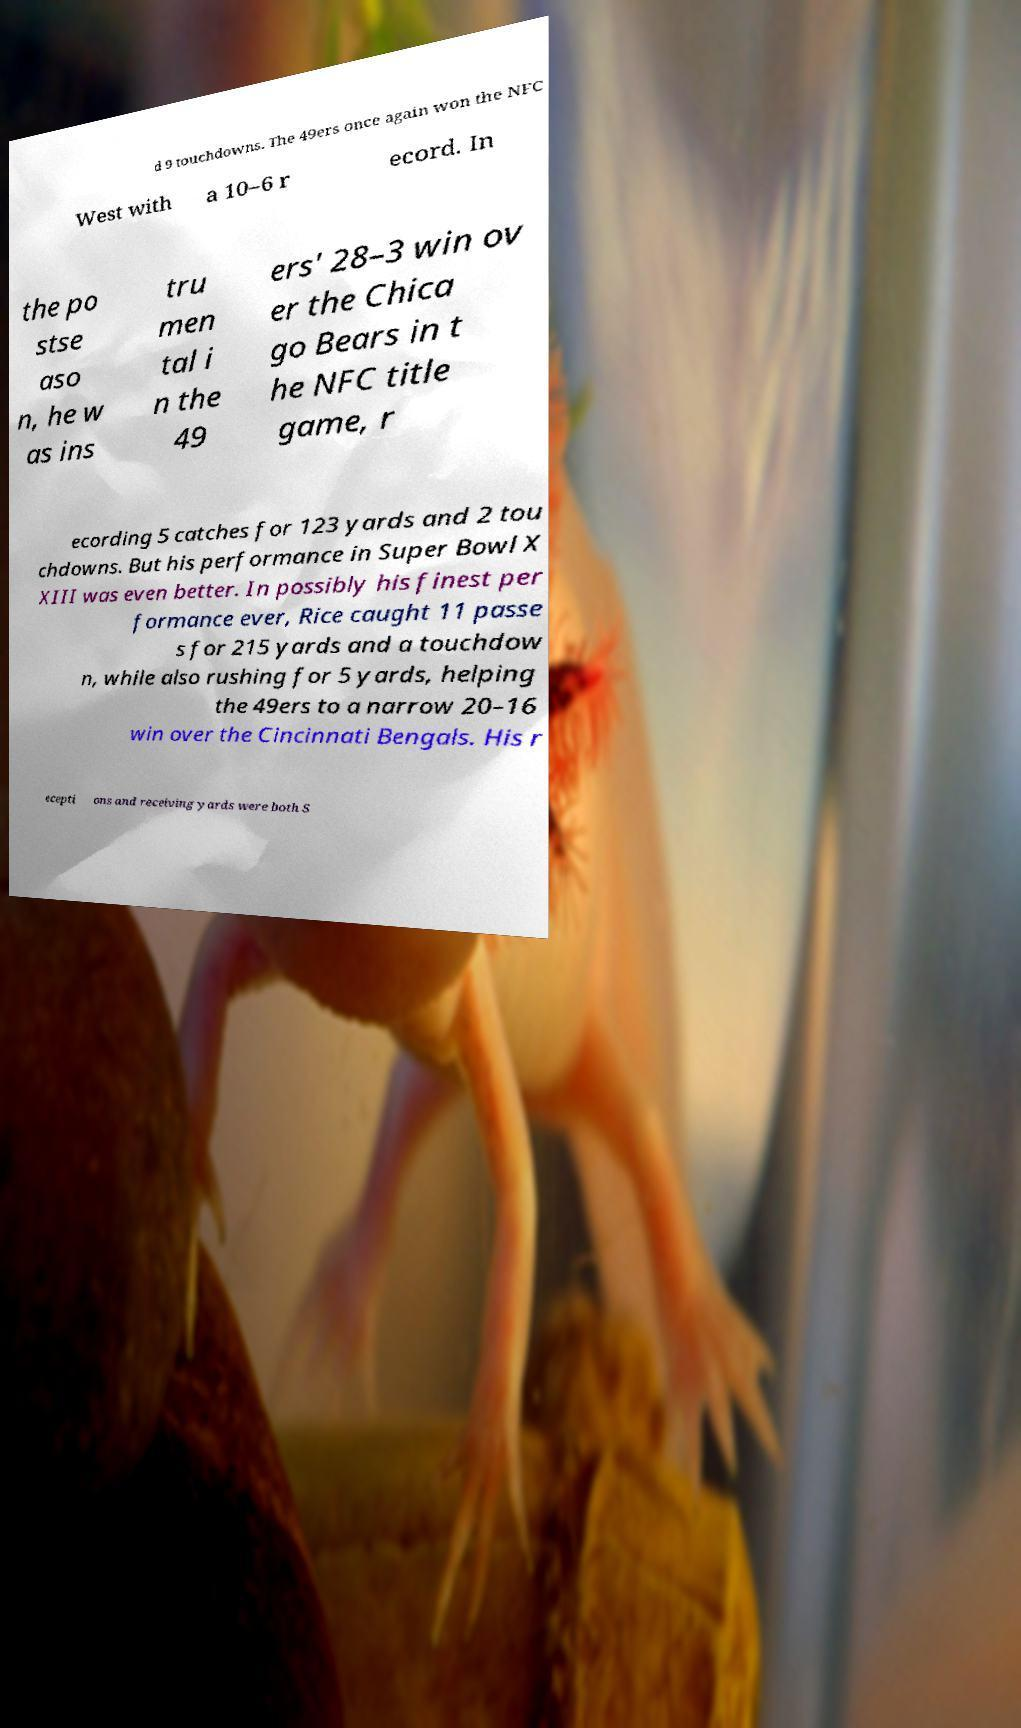Please read and relay the text visible in this image. What does it say? d 9 touchdowns. The 49ers once again won the NFC West with a 10–6 r ecord. In the po stse aso n, he w as ins tru men tal i n the 49 ers' 28–3 win ov er the Chica go Bears in t he NFC title game, r ecording 5 catches for 123 yards and 2 tou chdowns. But his performance in Super Bowl X XIII was even better. In possibly his finest per formance ever, Rice caught 11 passe s for 215 yards and a touchdow n, while also rushing for 5 yards, helping the 49ers to a narrow 20–16 win over the Cincinnati Bengals. His r ecepti ons and receiving yards were both S 